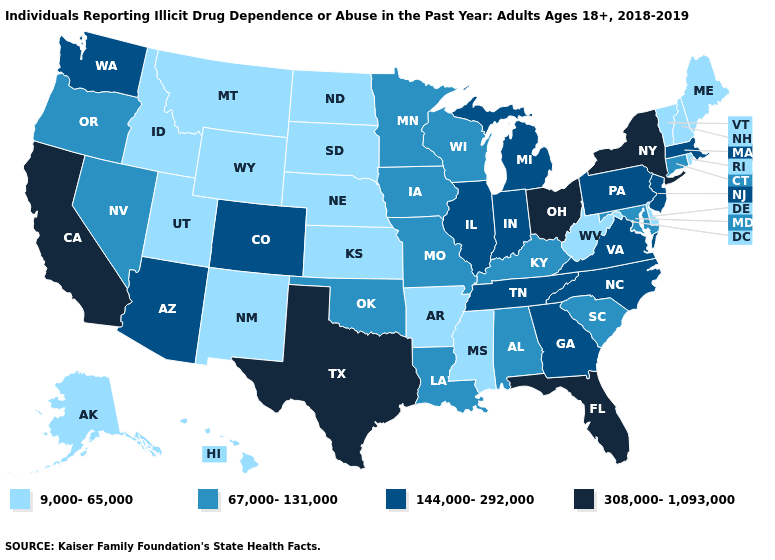Does Colorado have a lower value than California?
Write a very short answer. Yes. Name the states that have a value in the range 308,000-1,093,000?
Write a very short answer. California, Florida, New York, Ohio, Texas. Name the states that have a value in the range 67,000-131,000?
Write a very short answer. Alabama, Connecticut, Iowa, Kentucky, Louisiana, Maryland, Minnesota, Missouri, Nevada, Oklahoma, Oregon, South Carolina, Wisconsin. Among the states that border New York , which have the lowest value?
Keep it brief. Vermont. Which states hav the highest value in the MidWest?
Give a very brief answer. Ohio. What is the highest value in the USA?
Give a very brief answer. 308,000-1,093,000. Name the states that have a value in the range 308,000-1,093,000?
Give a very brief answer. California, Florida, New York, Ohio, Texas. Name the states that have a value in the range 9,000-65,000?
Write a very short answer. Alaska, Arkansas, Delaware, Hawaii, Idaho, Kansas, Maine, Mississippi, Montana, Nebraska, New Hampshire, New Mexico, North Dakota, Rhode Island, South Dakota, Utah, Vermont, West Virginia, Wyoming. What is the value of Hawaii?
Be succinct. 9,000-65,000. What is the value of New York?
Short answer required. 308,000-1,093,000. Does Maine have the highest value in the Northeast?
Keep it brief. No. Does Montana have the lowest value in the USA?
Quick response, please. Yes. What is the value of Arizona?
Keep it brief. 144,000-292,000. What is the highest value in states that border Mississippi?
Concise answer only. 144,000-292,000. 